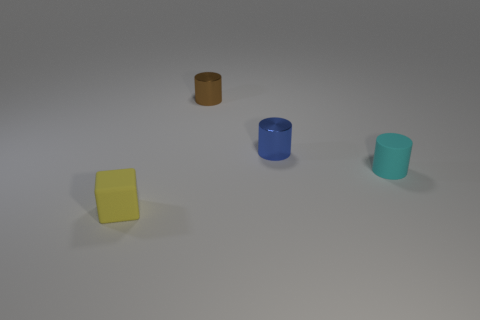Is the number of tiny cyan matte objects that are on the left side of the small block less than the number of tiny brown metallic objects that are on the right side of the small brown shiny object?
Provide a succinct answer. No. There is a rubber thing that is behind the block; does it have the same size as the tiny blue cylinder?
Offer a very short reply. Yes. The matte object that is left of the tiny brown shiny object has what shape?
Your answer should be compact. Cube. Are there more purple rubber spheres than yellow objects?
Ensure brevity in your answer.  No. There is a rubber thing left of the small brown thing; does it have the same color as the tiny rubber cylinder?
Keep it short and to the point. No. What number of things are things that are on the right side of the cube or things that are in front of the tiny cyan matte object?
Give a very brief answer. 4. What number of things are both in front of the cyan rubber cylinder and on the right side of the tiny yellow matte cube?
Provide a short and direct response. 0. Is the small yellow thing made of the same material as the brown thing?
Provide a short and direct response. No. What shape is the tiny matte thing to the left of the matte thing behind the object left of the brown cylinder?
Give a very brief answer. Cube. What is the thing that is both in front of the blue metallic cylinder and behind the small matte block made of?
Provide a succinct answer. Rubber. 